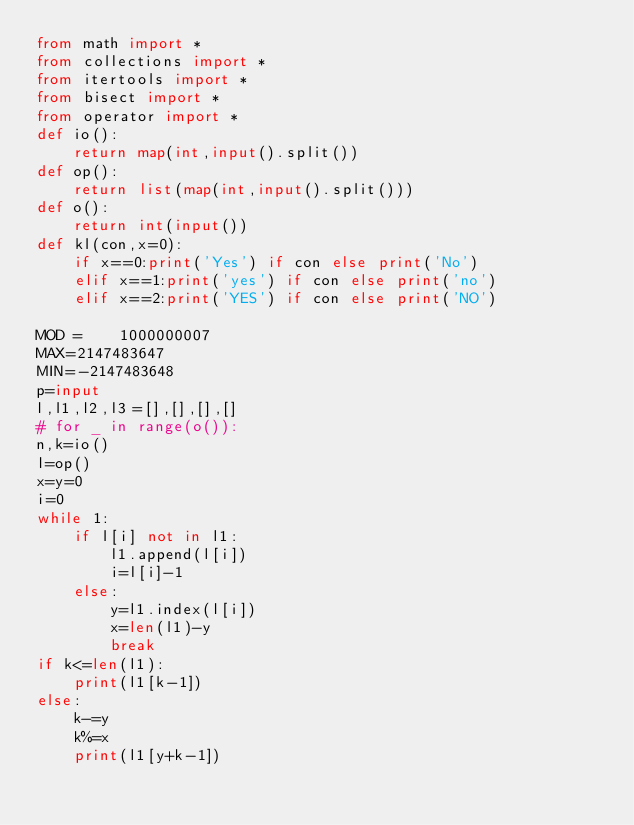<code> <loc_0><loc_0><loc_500><loc_500><_Python_>from math import *
from collections import *
from itertools import *
from bisect import *
from operator import *
def io():
    return map(int,input().split())
def op():
    return list(map(int,input().split()))
def o():
    return int(input())
def kl(con,x=0):
    if x==0:print('Yes') if con else print('No')
    elif x==1:print('yes') if con else print('no')
    elif x==2:print('YES') if con else print('NO')

MOD =    1000000007
MAX=2147483647
MIN=-2147483648
p=input
l,l1,l2,l3=[],[],[],[]
# for _ in range(o()):
n,k=io()
l=op()
x=y=0
i=0
while 1:
    if l[i] not in l1:
        l1.append(l[i])
        i=l[i]-1
    else:
        y=l1.index(l[i])
        x=len(l1)-y
        break
if k<=len(l1):
    print(l1[k-1])
else:
    k-=y
    k%=x
    print(l1[y+k-1])

</code> 